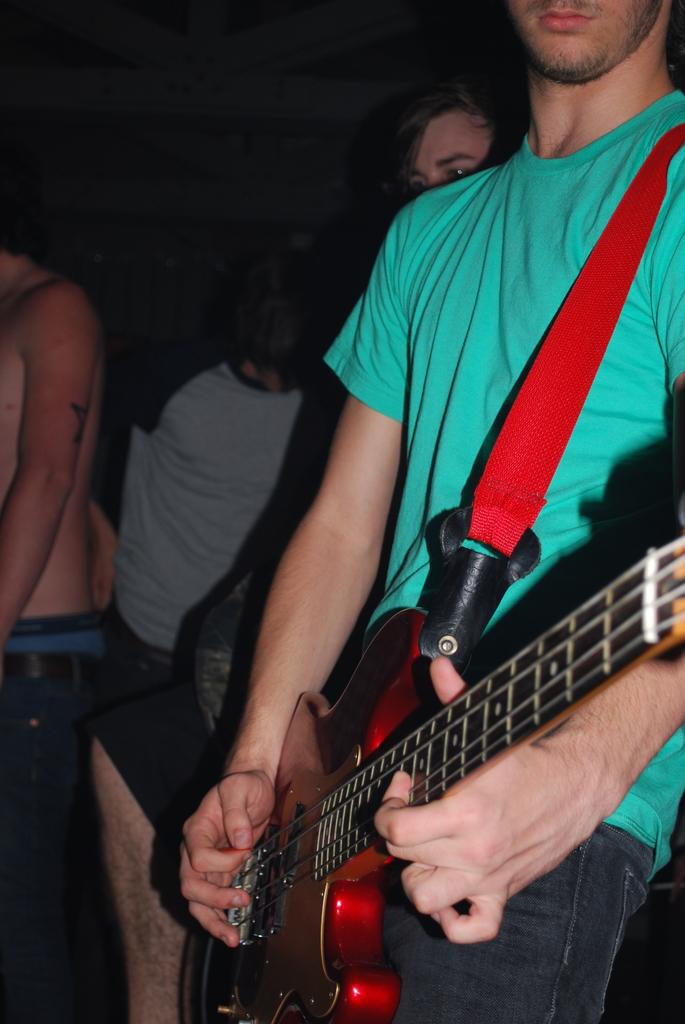How many people are in the image? There are persons standing in the image. What is one of the persons holding? One of the persons is holding a guitar. What direction is the owl facing in the image? There is no owl present in the image. 